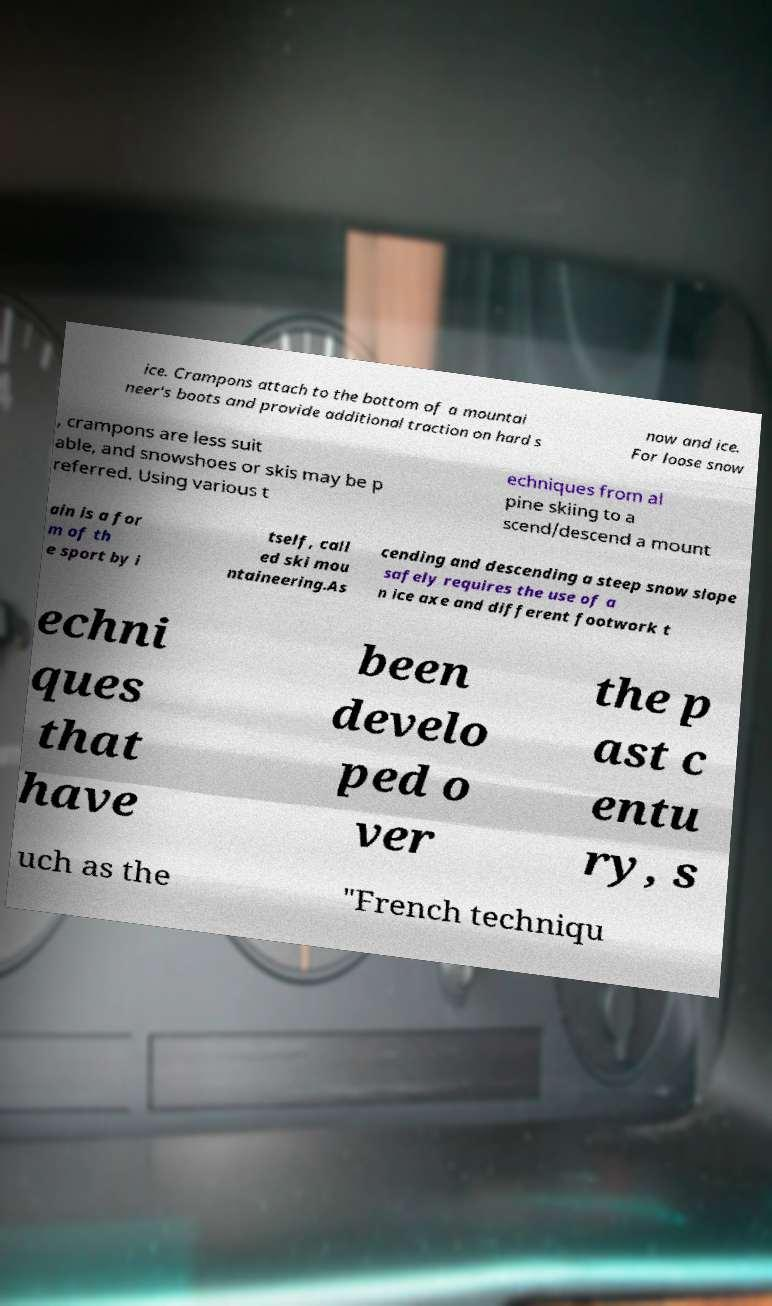Could you assist in decoding the text presented in this image and type it out clearly? ice. Crampons attach to the bottom of a mountai neer's boots and provide additional traction on hard s now and ice. For loose snow , crampons are less suit able, and snowshoes or skis may be p referred. Using various t echniques from al pine skiing to a scend/descend a mount ain is a for m of th e sport by i tself, call ed ski mou ntaineering.As cending and descending a steep snow slope safely requires the use of a n ice axe and different footwork t echni ques that have been develo ped o ver the p ast c entu ry, s uch as the "French techniqu 